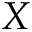Convert formula to latex. <formula><loc_0><loc_0><loc_500><loc_500>X</formula> 